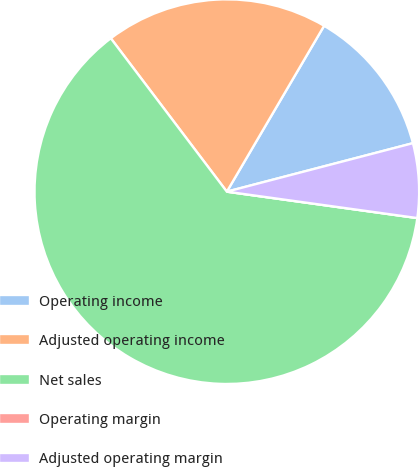<chart> <loc_0><loc_0><loc_500><loc_500><pie_chart><fcel>Operating income<fcel>Adjusted operating income<fcel>Net sales<fcel>Operating margin<fcel>Adjusted operating margin<nl><fcel>12.5%<fcel>18.75%<fcel>62.5%<fcel>0.0%<fcel>6.25%<nl></chart> 